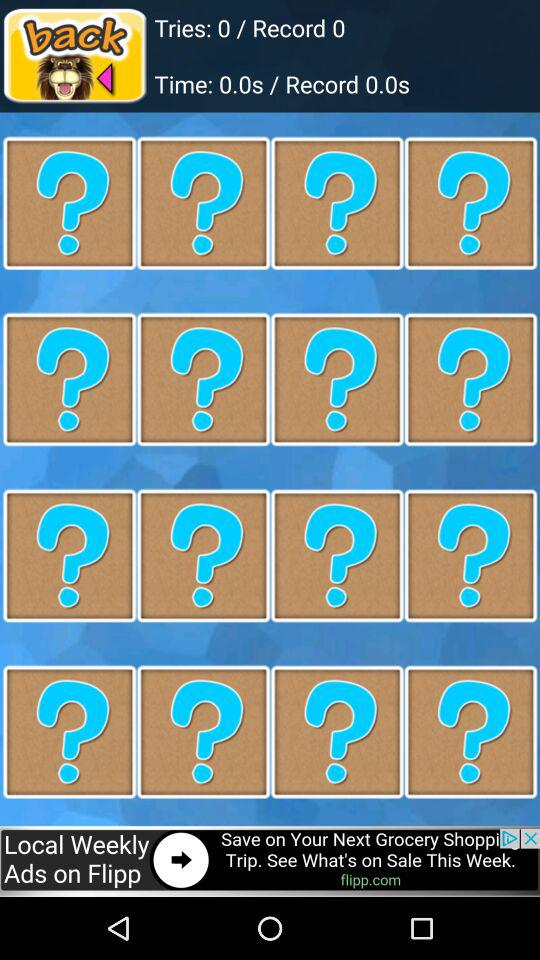How many tries are there? There are 0 tries. 